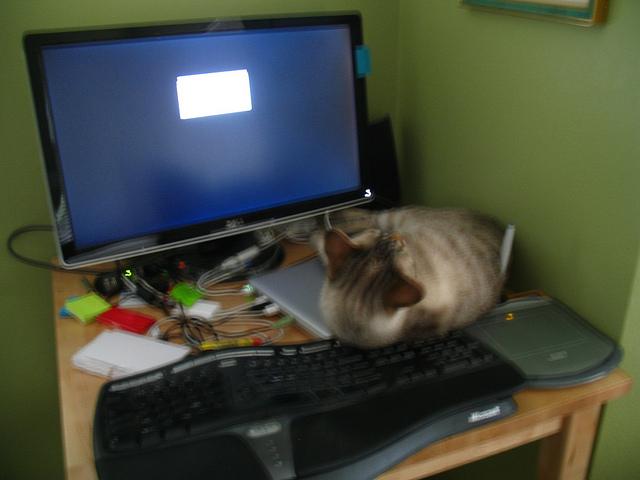What OS is the boy using?
Short answer required. Windows. What is that animal?
Quick response, please. Cat. What object is the cat on top of?
Give a very brief answer. Keyboard. What color is the kitty cat?
Give a very brief answer. Gray. Is the cat doing some research on the computer?
Short answer required. No. Is the computer on or off?
Quick response, please. On. What is that green thing laying on desk?
Short answer required. Paper. What is the cat watching?
Keep it brief. Computer. Are the computers on?
Write a very short answer. Yes. What color are the cats?
Keep it brief. Brown. What kind of animal is this?
Quick response, please. Cat. Is the cat tired?
Write a very short answer. Yes. What color is the mouse pad?
Short answer required. Gray. What color is the wall?
Short answer required. Green. What color is the cat's head?
Keep it brief. Tan and black. 